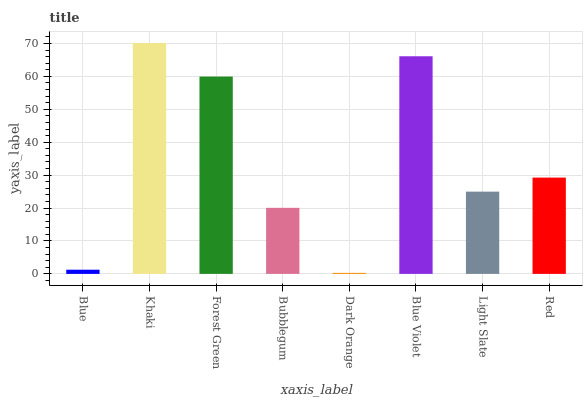Is Dark Orange the minimum?
Answer yes or no. Yes. Is Khaki the maximum?
Answer yes or no. Yes. Is Forest Green the minimum?
Answer yes or no. No. Is Forest Green the maximum?
Answer yes or no. No. Is Khaki greater than Forest Green?
Answer yes or no. Yes. Is Forest Green less than Khaki?
Answer yes or no. Yes. Is Forest Green greater than Khaki?
Answer yes or no. No. Is Khaki less than Forest Green?
Answer yes or no. No. Is Red the high median?
Answer yes or no. Yes. Is Light Slate the low median?
Answer yes or no. Yes. Is Light Slate the high median?
Answer yes or no. No. Is Forest Green the low median?
Answer yes or no. No. 